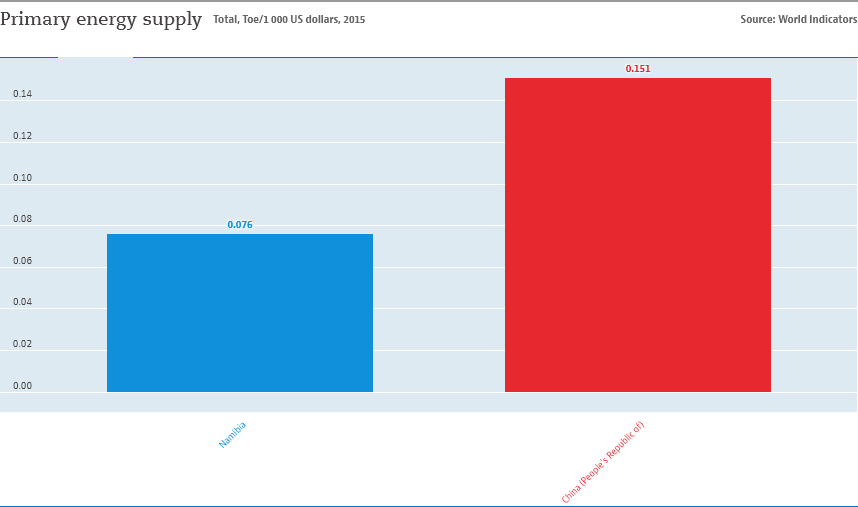Highlight a few significant elements in this photo. The sum value of Namibia and China is 0.227... The blue bar represents the country of Namibia, which is located in southern Africa. 